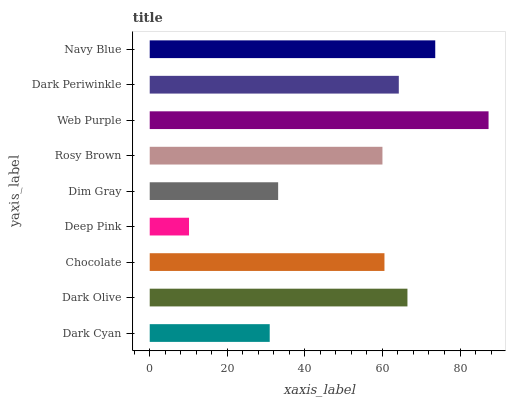Is Deep Pink the minimum?
Answer yes or no. Yes. Is Web Purple the maximum?
Answer yes or no. Yes. Is Dark Olive the minimum?
Answer yes or no. No. Is Dark Olive the maximum?
Answer yes or no. No. Is Dark Olive greater than Dark Cyan?
Answer yes or no. Yes. Is Dark Cyan less than Dark Olive?
Answer yes or no. Yes. Is Dark Cyan greater than Dark Olive?
Answer yes or no. No. Is Dark Olive less than Dark Cyan?
Answer yes or no. No. Is Chocolate the high median?
Answer yes or no. Yes. Is Chocolate the low median?
Answer yes or no. Yes. Is Dark Cyan the high median?
Answer yes or no. No. Is Dark Olive the low median?
Answer yes or no. No. 